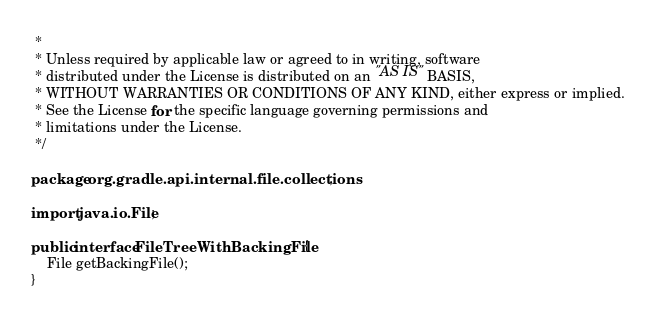Convert code to text. <code><loc_0><loc_0><loc_500><loc_500><_Java_> *
 * Unless required by applicable law or agreed to in writing, software
 * distributed under the License is distributed on an "AS IS" BASIS,
 * WITHOUT WARRANTIES OR CONDITIONS OF ANY KIND, either express or implied.
 * See the License for the specific language governing permissions and
 * limitations under the License.
 */

package org.gradle.api.internal.file.collections;

import java.io.File;

public interface FileTreeWithBackingFile {
    File getBackingFile();
}
</code> 